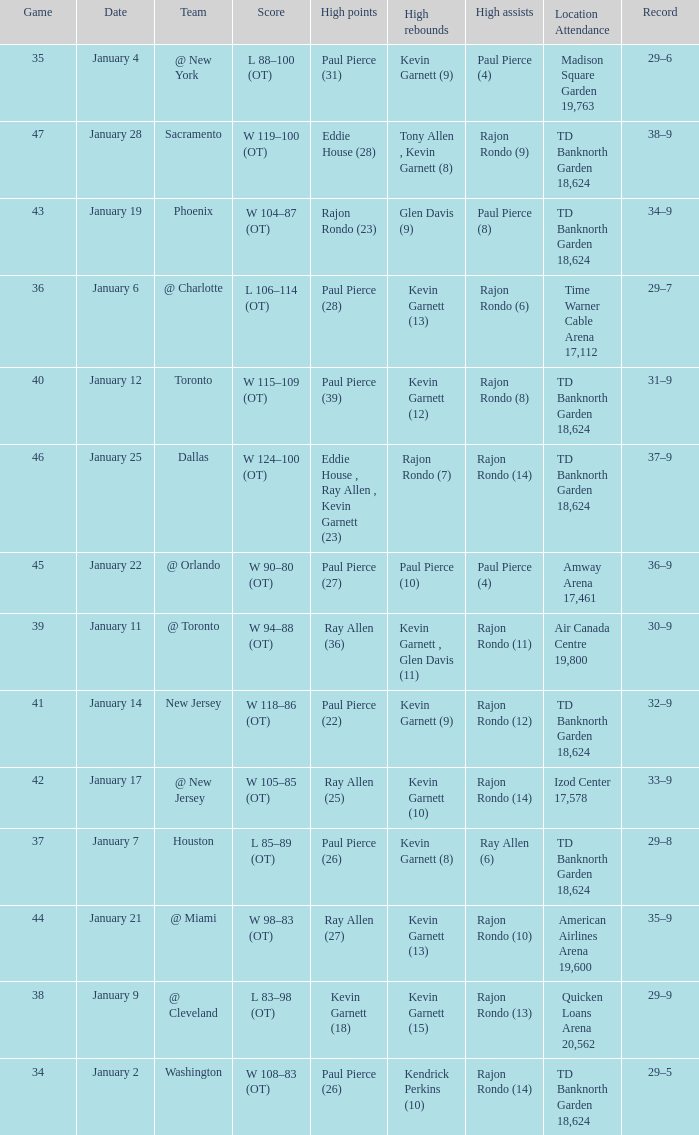Who had the high rebound total on january 6? Kevin Garnett (13). 